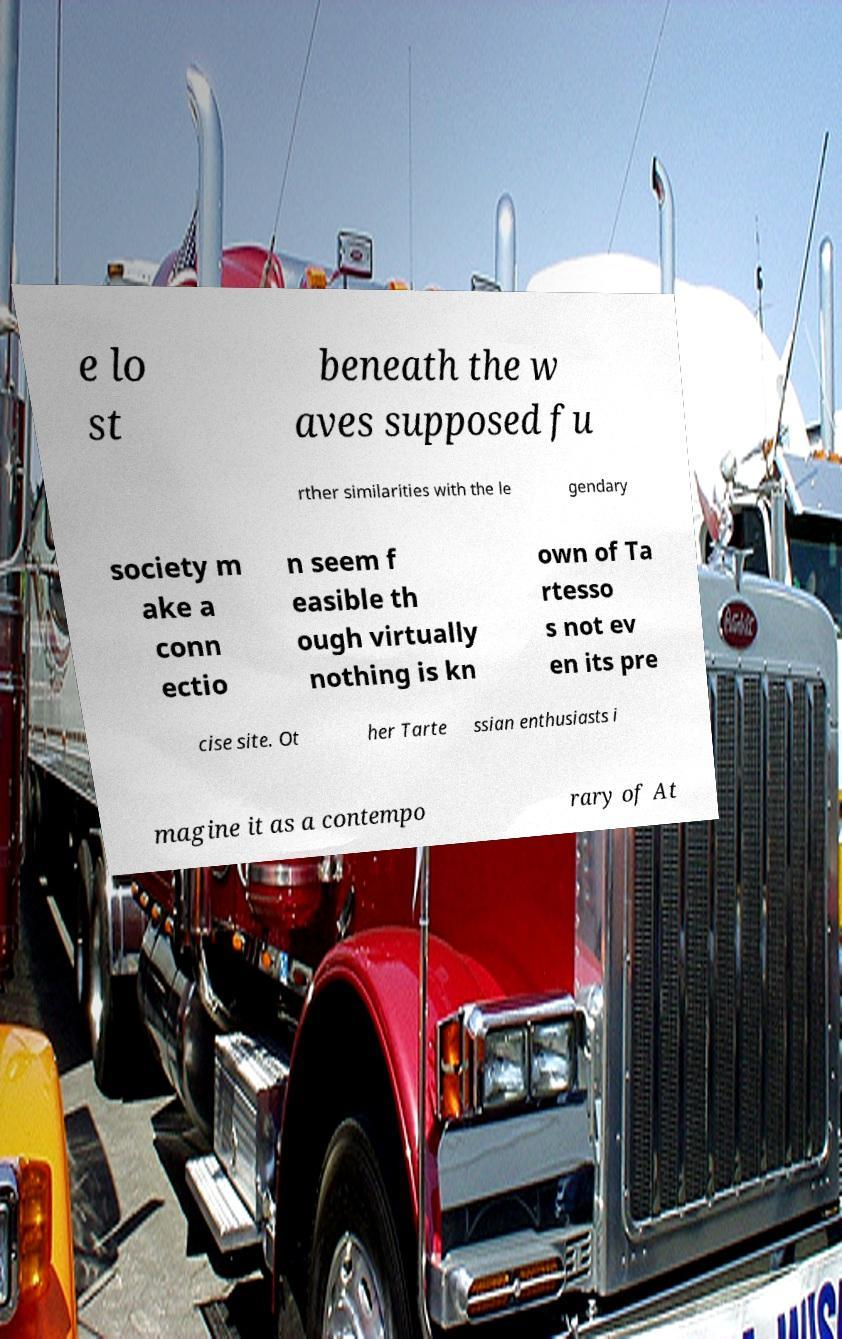Please read and relay the text visible in this image. What does it say? e lo st beneath the w aves supposed fu rther similarities with the le gendary society m ake a conn ectio n seem f easible th ough virtually nothing is kn own of Ta rtesso s not ev en its pre cise site. Ot her Tarte ssian enthusiasts i magine it as a contempo rary of At 